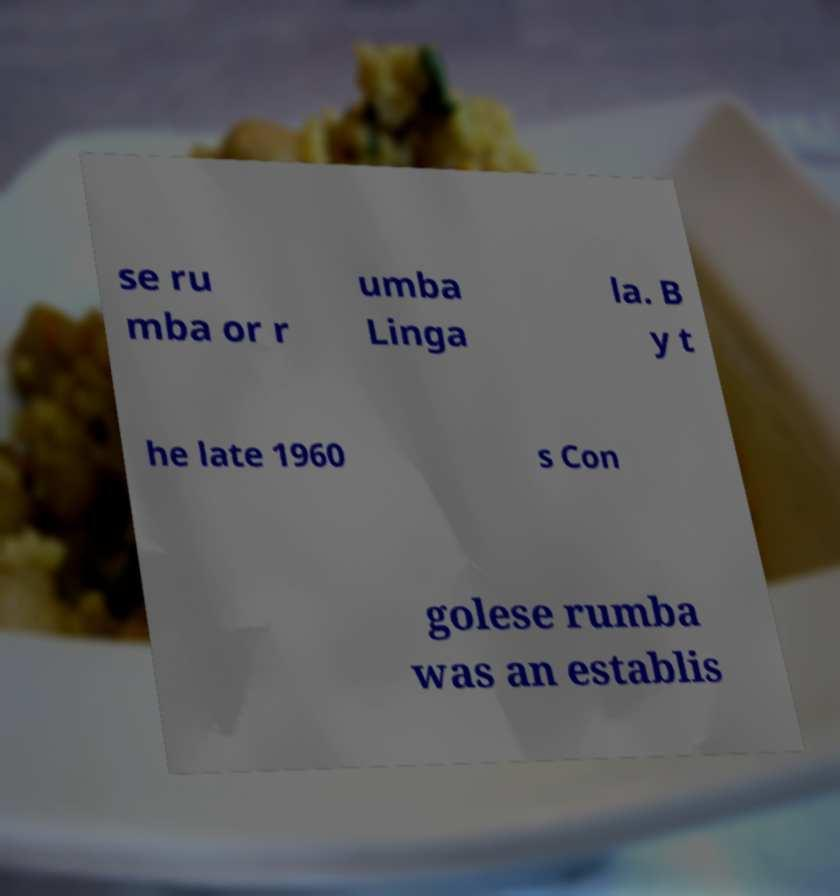What messages or text are displayed in this image? I need them in a readable, typed format. se ru mba or r umba Linga la. B y t he late 1960 s Con golese rumba was an establis 